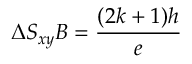<formula> <loc_0><loc_0><loc_500><loc_500>\Delta S _ { x y } B = \frac { ( 2 k + 1 ) h } { e }</formula> 